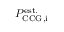Convert formula to latex. <formula><loc_0><loc_0><loc_500><loc_500>P _ { C C G , i } ^ { e s t . }</formula> 